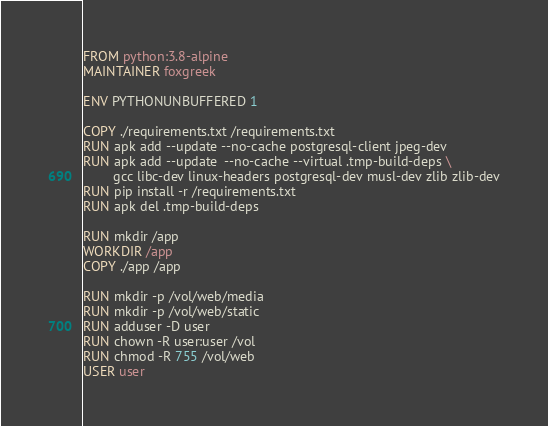<code> <loc_0><loc_0><loc_500><loc_500><_Dockerfile_>FROM python:3.8-alpine
MAINTAINER foxgreek

ENV PYTHONUNBUFFERED 1

COPY ./requirements.txt /requirements.txt
RUN apk add --update --no-cache postgresql-client jpeg-dev
RUN apk add --update  --no-cache --virtual .tmp-build-deps \
        gcc libc-dev linux-headers postgresql-dev musl-dev zlib zlib-dev
RUN pip install -r /requirements.txt
RUN apk del .tmp-build-deps

RUN mkdir /app
WORKDIR /app
COPY ./app /app

RUN mkdir -p /vol/web/media
RUN mkdir -p /vol/web/static
RUN adduser -D user
RUN chown -R user:user /vol
RUN chmod -R 755 /vol/web
USER user</code> 